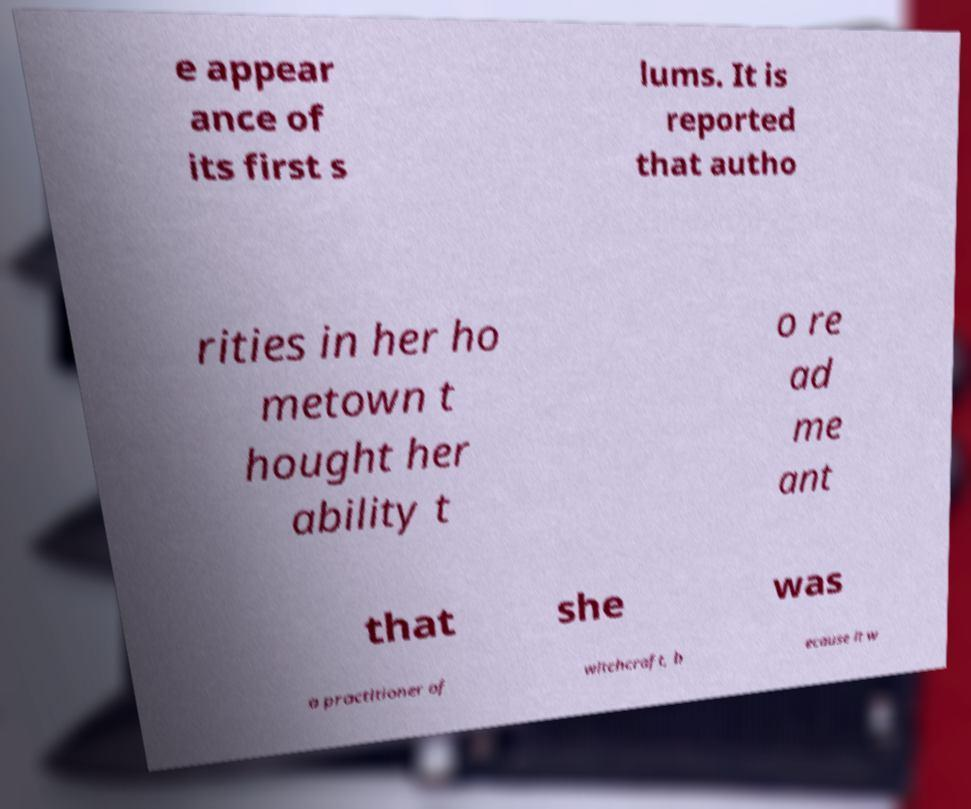What messages or text are displayed in this image? I need them in a readable, typed format. e appear ance of its first s lums. It is reported that autho rities in her ho metown t hought her ability t o re ad me ant that she was a practitioner of witchcraft, b ecause it w 